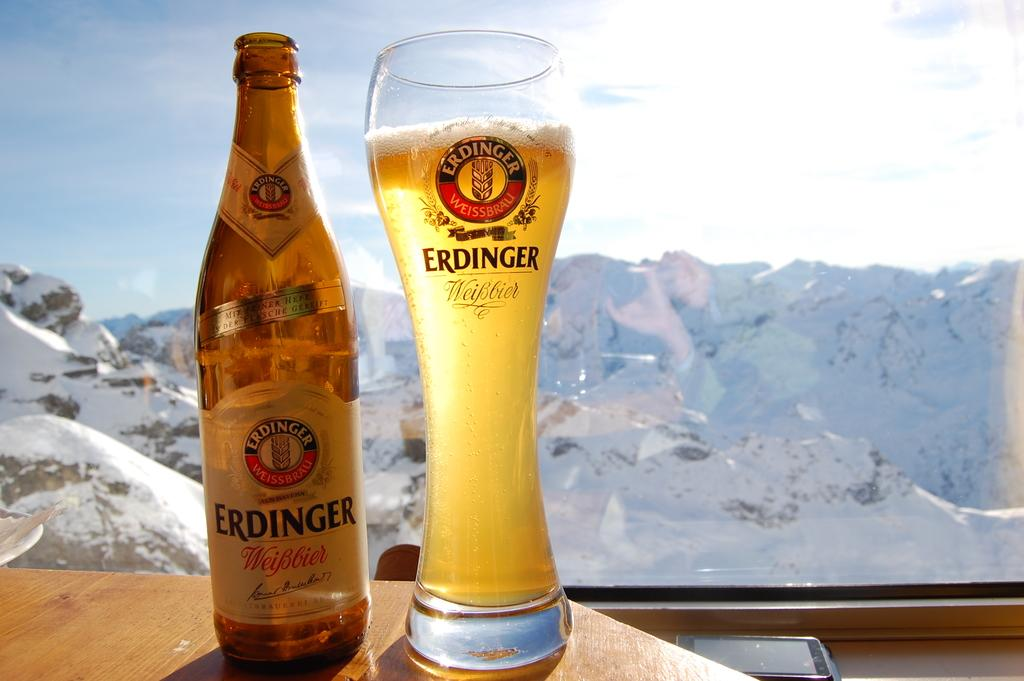<image>
Provide a brief description of the given image. A bottle of Erdinger Weibbier beer is next to a full glass with snowy mountains in the background. 